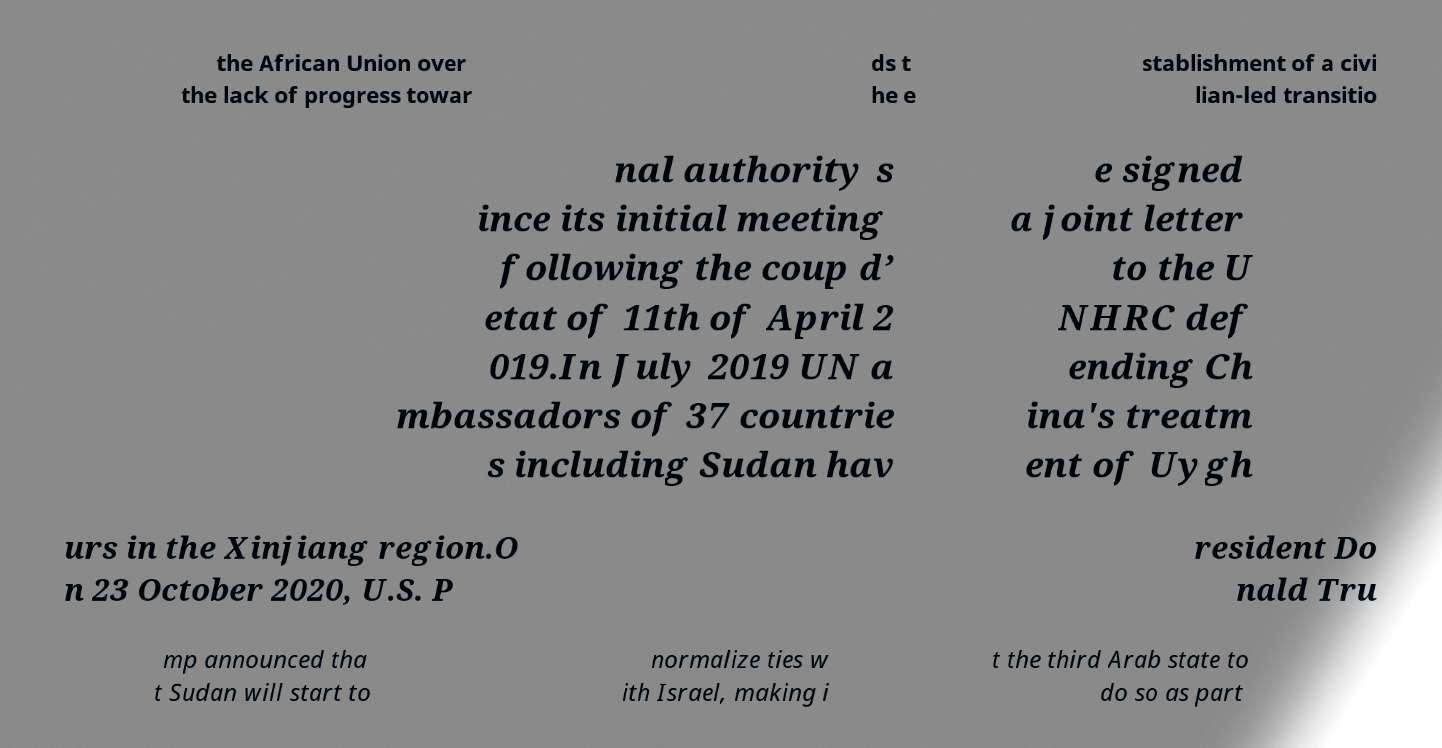For documentation purposes, I need the text within this image transcribed. Could you provide that? the African Union over the lack of progress towar ds t he e stablishment of a civi lian-led transitio nal authority s ince its initial meeting following the coup d’ etat of 11th of April 2 019.In July 2019 UN a mbassadors of 37 countrie s including Sudan hav e signed a joint letter to the U NHRC def ending Ch ina's treatm ent of Uygh urs in the Xinjiang region.O n 23 October 2020, U.S. P resident Do nald Tru mp announced tha t Sudan will start to normalize ties w ith Israel, making i t the third Arab state to do so as part 